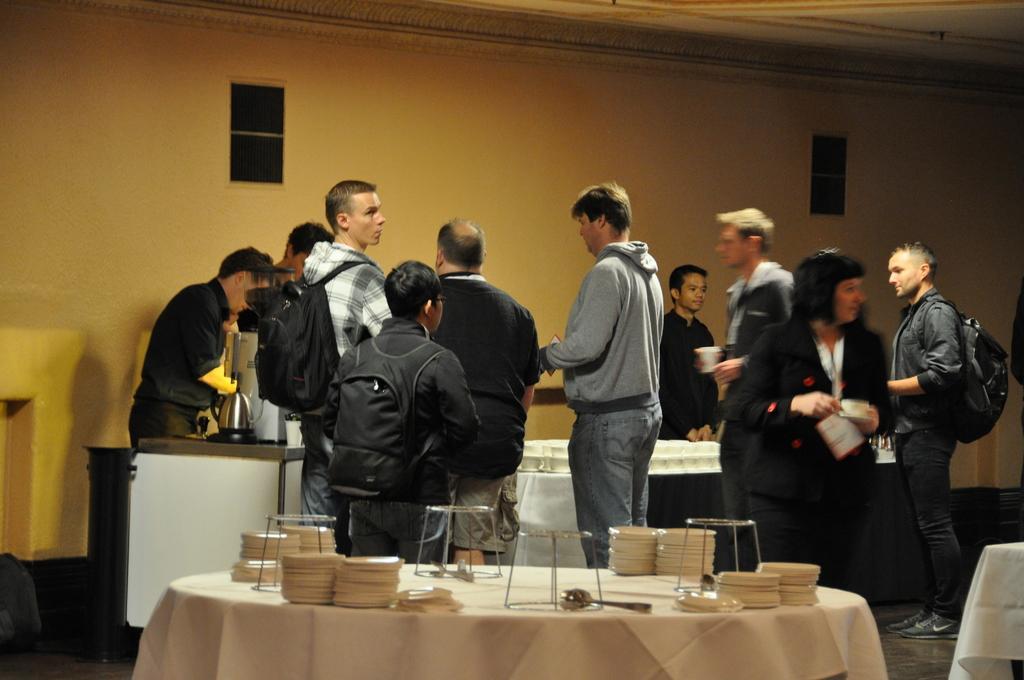In one or two sentences, can you explain what this image depicts? In this image there are group of persons standing and walking in the center. In the front there is a table which is covered with a white colour cloth, on the table there are plates, there are glasses, and there are spoons. In the background there is a man wearing a black colour bag and standing. Behind the man there is a table and on the table there are objects which are white in colour and there is a jar. 